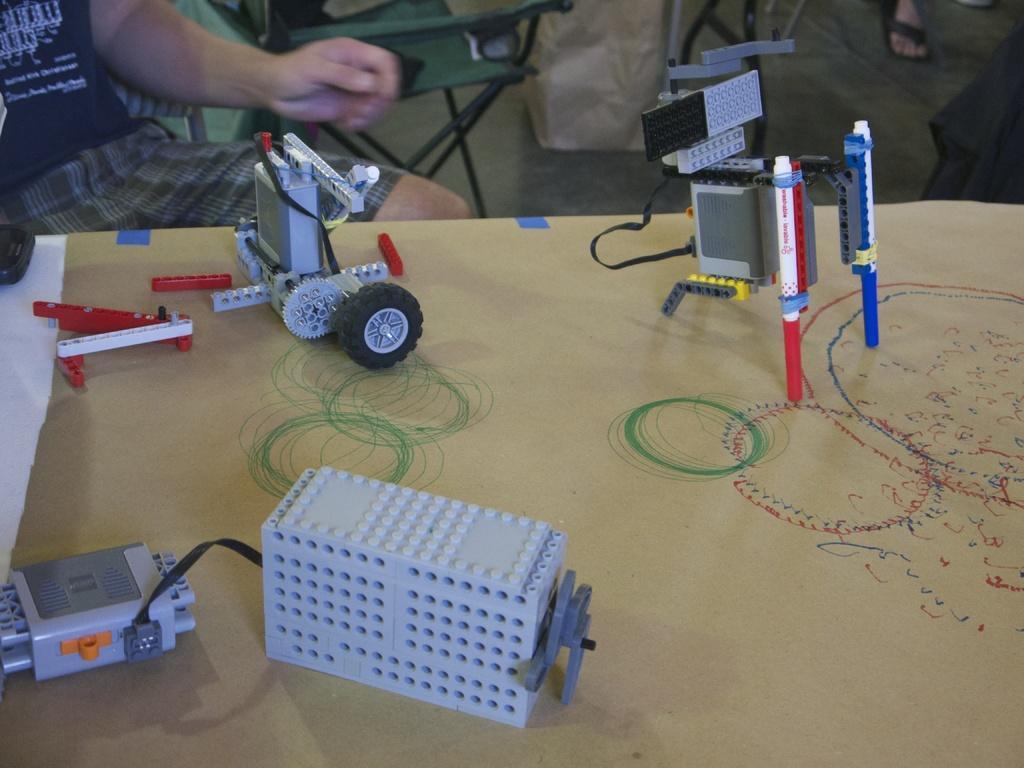How would you summarize this image in a sentence or two? In this image we can see some electronic circuits on the wooden surface. And we can see the human hands. 